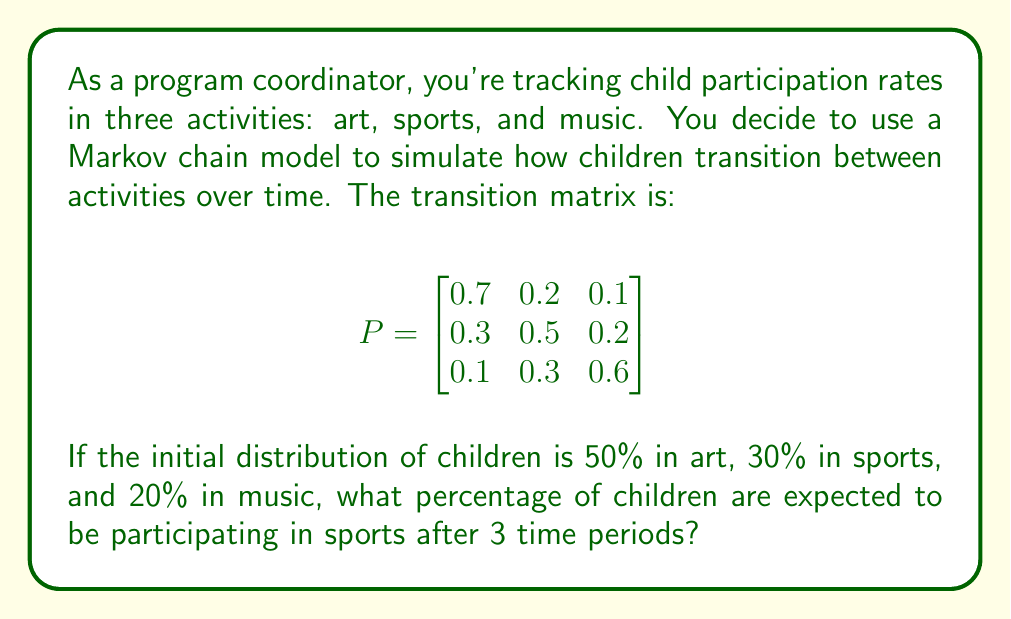Can you answer this question? To solve this problem, we'll follow these steps:

1) First, let's define our initial state vector:
   $$x_0 = \begin{bmatrix} 0.5 \\ 0.3 \\ 0.2 \end{bmatrix}$$

2) To find the state after 3 time periods, we need to multiply the initial state by the transition matrix 3 times:
   $$x_3 = P^3 \cdot x_0$$

3) Let's calculate $P^3$:
   $$P^2 = P \cdot P = \begin{bmatrix}
   0.55 & 0.28 & 0.17 \\
   0.37 & 0.40 & 0.23 \\
   0.22 & 0.33 & 0.45
   \end{bmatrix}$$

   $$P^3 = P^2 \cdot P = \begin{bmatrix}
   0.481 & 0.314 & 0.205 \\
   0.403 & 0.365 & 0.232 \\
   0.298 & 0.342 & 0.360
   \end{bmatrix}$$

4) Now we can multiply $P^3$ by $x_0$:
   $$x_3 = P^3 \cdot x_0 = \begin{bmatrix}
   0.481 & 0.314 & 0.205 \\
   0.403 & 0.365 & 0.232 \\
   0.298 & 0.342 & 0.360
   \end{bmatrix} \cdot \begin{bmatrix} 0.5 \\ 0.3 \\ 0.2 \end{bmatrix}$$

5) Performing the matrix multiplication:
   $$x_3 = \begin{bmatrix}
   0.4405 \\
   0.3764 \\
   0.3231
   \end{bmatrix}$$

6) The second element of this vector represents the proportion of children in sports after 3 time periods.

Therefore, after 3 time periods, approximately 37.64% of children are expected to be participating in sports.
Answer: 37.64% 